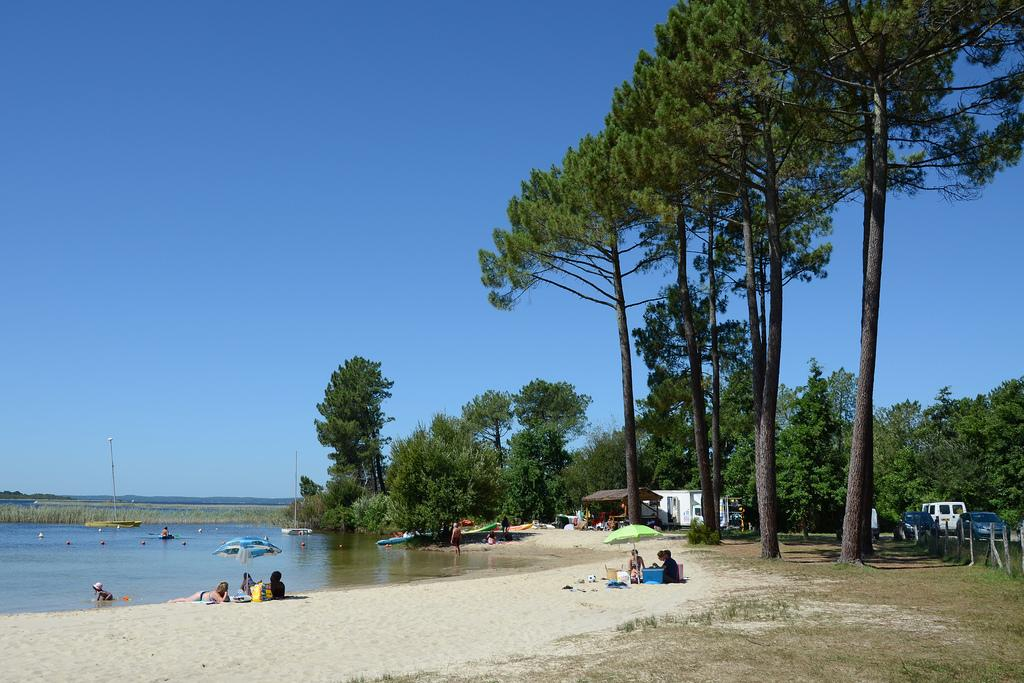What objects are present in the image for protection from the sun or rain? There are umbrellas in the image. What type of surface are the people sitting on in the image? The group of people is sitting on sand in the image. What is the person laying on in the image? The person is laying on a mat in the image. What items might the people be using to carry their belongings? There are bags in the image. What types of transportation can be seen in the image? There are vehicles in the image. What structures are present in the image that might be used for support or signage? There are poles in the image. What type of vegetation is visible in the image? There is grass in the image. What type of man-made structures can be seen in the image? There are buildings in the image. What type of natural structures can be seen in the image? There are trees in the image. What type of watercraft can be seen in the image? There are boats in the image. What natural element is visible in the image? There is water visible in the image. What part of the natural environment is visible in the image? There is sky visible in the image. What caption can be seen on the image? There is no caption present in the image. What type of crime is being committed in the image? There is no crime being committed in the image. What type of cloth is being used to cover the person laying on the mat? The person laying on the mat is not covered by any cloth in the image. 